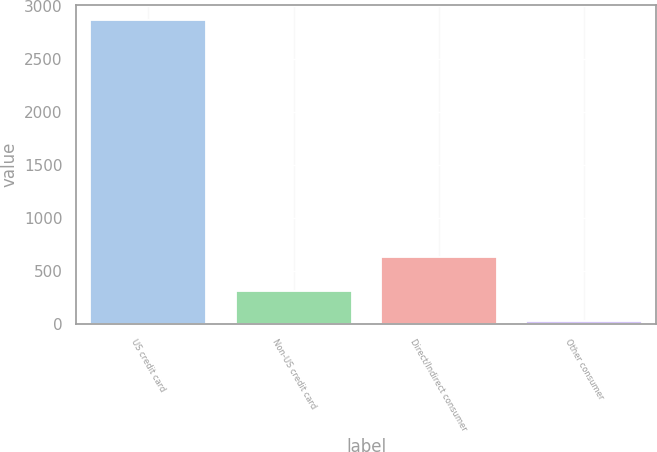Convert chart. <chart><loc_0><loc_0><loc_500><loc_500><bar_chart><fcel>US credit card<fcel>Non-US credit card<fcel>Direct/Indirect consumer<fcel>Other consumer<nl><fcel>2871<fcel>316<fcel>636<fcel>30<nl></chart> 